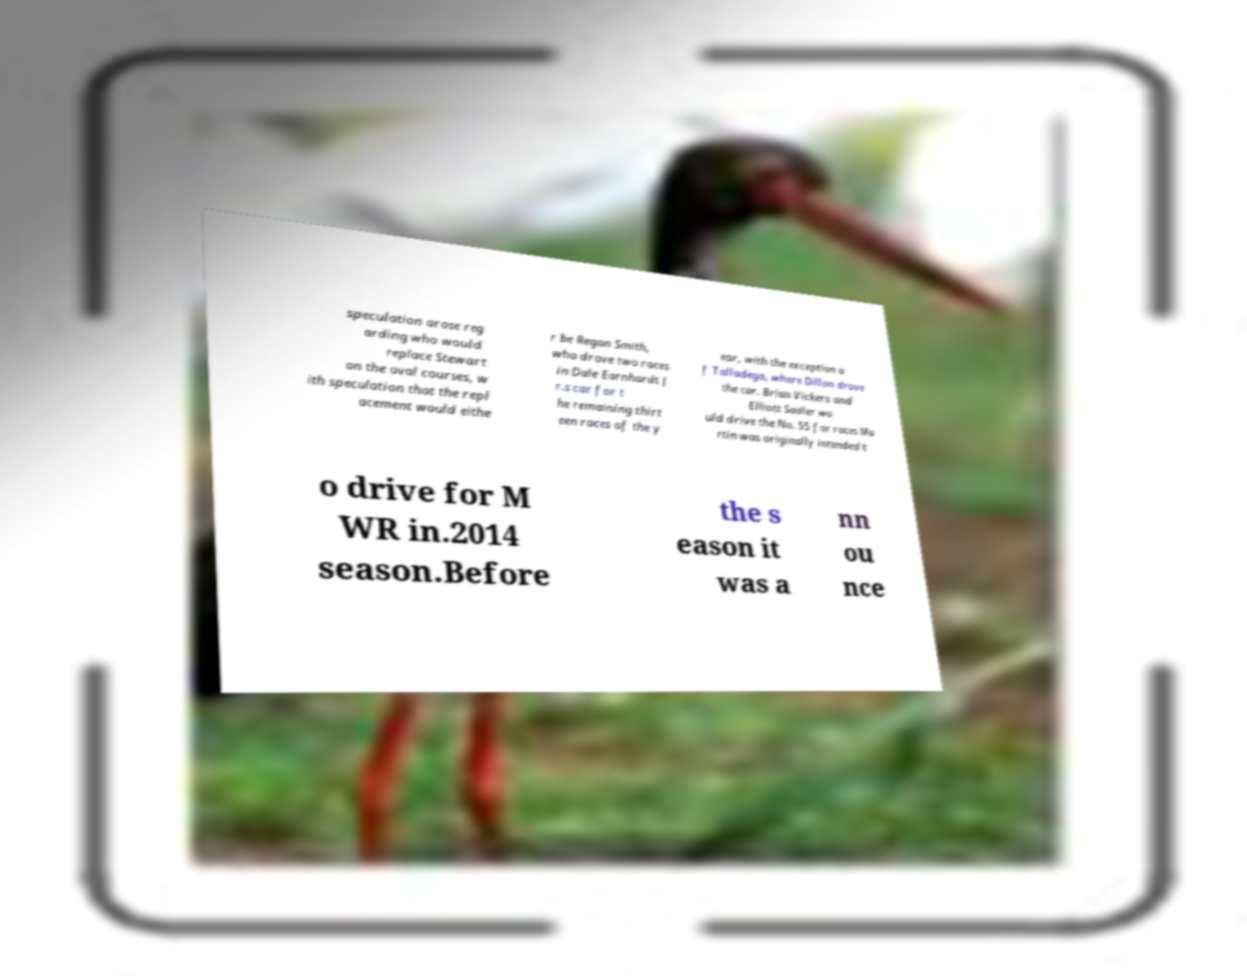What messages or text are displayed in this image? I need them in a readable, typed format. speculation arose reg arding who would replace Stewart on the oval courses, w ith speculation that the repl acement would eithe r be Regan Smith, who drove two races in Dale Earnhardt J r.s car for t he remaining thirt een races of the y ear, with the exception o f Talladega, where Dillon drove the car. Brian Vickers and Elliott Sadler wo uld drive the No. 55 for races Ma rtin was originally intended t o drive for M WR in.2014 season.Before the s eason it was a nn ou nce 